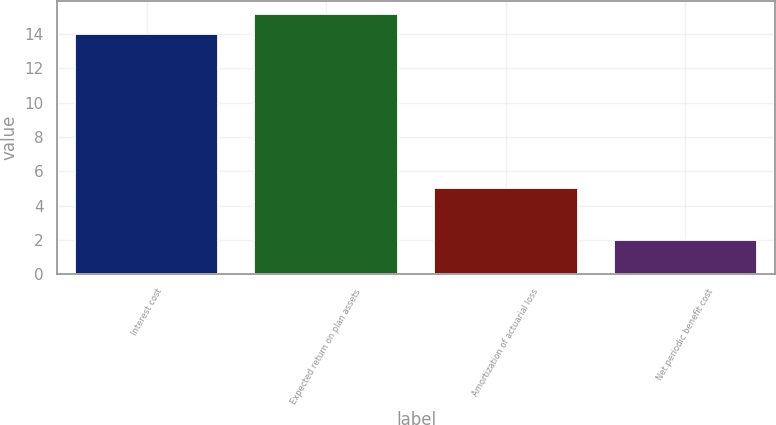<chart> <loc_0><loc_0><loc_500><loc_500><bar_chart><fcel>Interest cost<fcel>Expected return on plan assets<fcel>Amortization of actuarial loss<fcel>Net periodic benefit cost<nl><fcel>14<fcel>15.2<fcel>5<fcel>2<nl></chart> 